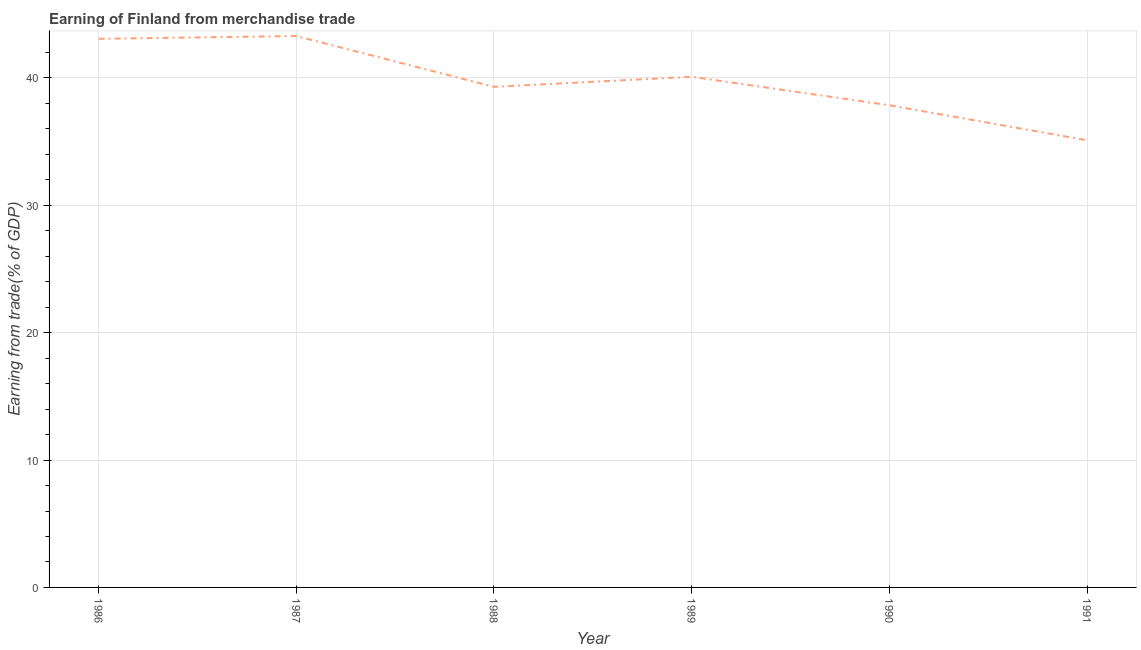What is the earning from merchandise trade in 1988?
Your response must be concise. 39.3. Across all years, what is the maximum earning from merchandise trade?
Your answer should be very brief. 43.29. Across all years, what is the minimum earning from merchandise trade?
Ensure brevity in your answer.  35.11. In which year was the earning from merchandise trade maximum?
Ensure brevity in your answer.  1987. What is the sum of the earning from merchandise trade?
Your response must be concise. 238.71. What is the difference between the earning from merchandise trade in 1989 and 1991?
Ensure brevity in your answer.  4.98. What is the average earning from merchandise trade per year?
Your response must be concise. 39.79. What is the median earning from merchandise trade?
Offer a very short reply. 39.7. In how many years, is the earning from merchandise trade greater than 28 %?
Your answer should be very brief. 6. Do a majority of the years between 1986 and 1988 (inclusive) have earning from merchandise trade greater than 20 %?
Your answer should be very brief. Yes. What is the ratio of the earning from merchandise trade in 1987 to that in 1990?
Ensure brevity in your answer.  1.14. Is the difference between the earning from merchandise trade in 1989 and 1991 greater than the difference between any two years?
Your answer should be very brief. No. What is the difference between the highest and the second highest earning from merchandise trade?
Provide a short and direct response. 0.22. What is the difference between the highest and the lowest earning from merchandise trade?
Offer a very short reply. 8.18. In how many years, is the earning from merchandise trade greater than the average earning from merchandise trade taken over all years?
Ensure brevity in your answer.  3. Does the earning from merchandise trade monotonically increase over the years?
Keep it short and to the point. No. How many lines are there?
Provide a succinct answer. 1. Are the values on the major ticks of Y-axis written in scientific E-notation?
Provide a short and direct response. No. What is the title of the graph?
Provide a short and direct response. Earning of Finland from merchandise trade. What is the label or title of the Y-axis?
Your response must be concise. Earning from trade(% of GDP). What is the Earning from trade(% of GDP) in 1986?
Provide a short and direct response. 43.07. What is the Earning from trade(% of GDP) in 1987?
Provide a succinct answer. 43.29. What is the Earning from trade(% of GDP) in 1988?
Ensure brevity in your answer.  39.3. What is the Earning from trade(% of GDP) in 1989?
Offer a terse response. 40.09. What is the Earning from trade(% of GDP) of 1990?
Ensure brevity in your answer.  37.86. What is the Earning from trade(% of GDP) in 1991?
Your answer should be compact. 35.11. What is the difference between the Earning from trade(% of GDP) in 1986 and 1987?
Offer a very short reply. -0.22. What is the difference between the Earning from trade(% of GDP) in 1986 and 1988?
Provide a succinct answer. 3.77. What is the difference between the Earning from trade(% of GDP) in 1986 and 1989?
Give a very brief answer. 2.98. What is the difference between the Earning from trade(% of GDP) in 1986 and 1990?
Make the answer very short. 5.22. What is the difference between the Earning from trade(% of GDP) in 1986 and 1991?
Give a very brief answer. 7.97. What is the difference between the Earning from trade(% of GDP) in 1987 and 1988?
Keep it short and to the point. 3.99. What is the difference between the Earning from trade(% of GDP) in 1987 and 1989?
Your answer should be compact. 3.2. What is the difference between the Earning from trade(% of GDP) in 1987 and 1990?
Make the answer very short. 5.43. What is the difference between the Earning from trade(% of GDP) in 1987 and 1991?
Ensure brevity in your answer.  8.18. What is the difference between the Earning from trade(% of GDP) in 1988 and 1989?
Provide a short and direct response. -0.79. What is the difference between the Earning from trade(% of GDP) in 1988 and 1990?
Provide a succinct answer. 1.45. What is the difference between the Earning from trade(% of GDP) in 1988 and 1991?
Make the answer very short. 4.19. What is the difference between the Earning from trade(% of GDP) in 1989 and 1990?
Ensure brevity in your answer.  2.24. What is the difference between the Earning from trade(% of GDP) in 1989 and 1991?
Offer a terse response. 4.98. What is the difference between the Earning from trade(% of GDP) in 1990 and 1991?
Ensure brevity in your answer.  2.75. What is the ratio of the Earning from trade(% of GDP) in 1986 to that in 1987?
Provide a short and direct response. 0.99. What is the ratio of the Earning from trade(% of GDP) in 1986 to that in 1988?
Offer a terse response. 1.1. What is the ratio of the Earning from trade(% of GDP) in 1986 to that in 1989?
Ensure brevity in your answer.  1.07. What is the ratio of the Earning from trade(% of GDP) in 1986 to that in 1990?
Give a very brief answer. 1.14. What is the ratio of the Earning from trade(% of GDP) in 1986 to that in 1991?
Ensure brevity in your answer.  1.23. What is the ratio of the Earning from trade(% of GDP) in 1987 to that in 1988?
Your answer should be compact. 1.1. What is the ratio of the Earning from trade(% of GDP) in 1987 to that in 1989?
Ensure brevity in your answer.  1.08. What is the ratio of the Earning from trade(% of GDP) in 1987 to that in 1990?
Ensure brevity in your answer.  1.14. What is the ratio of the Earning from trade(% of GDP) in 1987 to that in 1991?
Give a very brief answer. 1.23. What is the ratio of the Earning from trade(% of GDP) in 1988 to that in 1990?
Your answer should be compact. 1.04. What is the ratio of the Earning from trade(% of GDP) in 1988 to that in 1991?
Provide a succinct answer. 1.12. What is the ratio of the Earning from trade(% of GDP) in 1989 to that in 1990?
Your answer should be very brief. 1.06. What is the ratio of the Earning from trade(% of GDP) in 1989 to that in 1991?
Offer a terse response. 1.14. What is the ratio of the Earning from trade(% of GDP) in 1990 to that in 1991?
Offer a terse response. 1.08. 